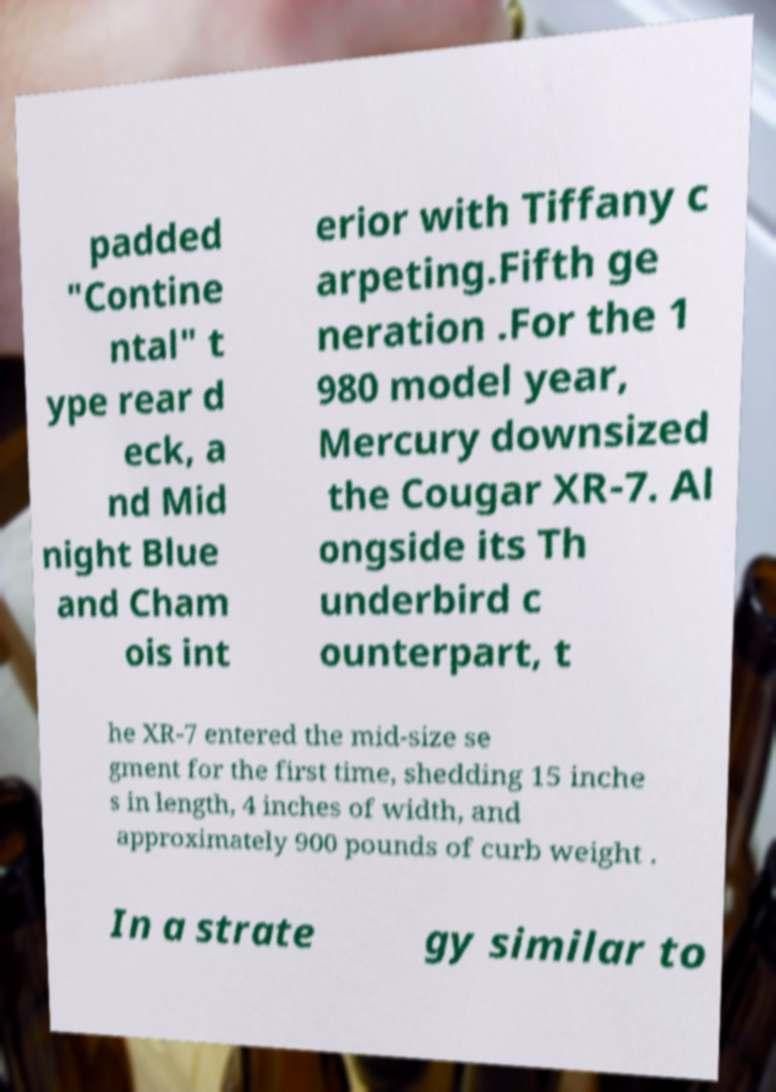For documentation purposes, I need the text within this image transcribed. Could you provide that? padded "Contine ntal" t ype rear d eck, a nd Mid night Blue and Cham ois int erior with Tiffany c arpeting.Fifth ge neration .For the 1 980 model year, Mercury downsized the Cougar XR-7. Al ongside its Th underbird c ounterpart, t he XR-7 entered the mid-size se gment for the first time, shedding 15 inche s in length, 4 inches of width, and approximately 900 pounds of curb weight . In a strate gy similar to 